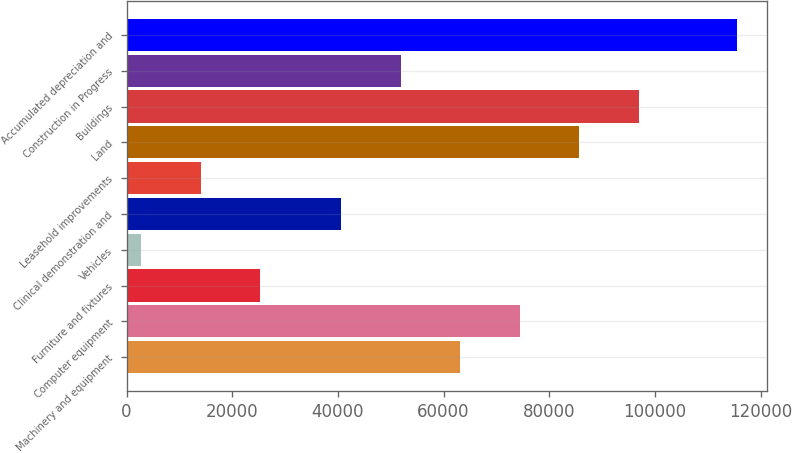Convert chart. <chart><loc_0><loc_0><loc_500><loc_500><bar_chart><fcel>Machinery and equipment<fcel>Computer equipment<fcel>Furniture and fixtures<fcel>Vehicles<fcel>Clinical demonstration and<fcel>Leasehold improvements<fcel>Land<fcel>Buildings<fcel>Construction in Progress<fcel>Accumulated depreciation and<nl><fcel>63150.2<fcel>74417.8<fcel>25330.2<fcel>2795<fcel>40615<fcel>14062.6<fcel>85685.4<fcel>96953<fcel>51882.6<fcel>115471<nl></chart> 